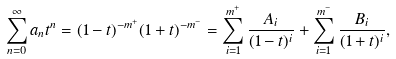<formula> <loc_0><loc_0><loc_500><loc_500>\sum _ { n = 0 } ^ { \infty } a _ { n } t ^ { n } = ( 1 - t ) ^ { - m ^ { + } } ( 1 + t ) ^ { - m ^ { - } } = \sum _ { i = 1 } ^ { m ^ { + } } \frac { A _ { i } } { ( 1 - t ) ^ { i } } + \sum _ { i = 1 } ^ { m ^ { - } } \frac { B _ { i } } { ( 1 + t ) ^ { i } } ,</formula> 